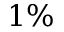Convert formula to latex. <formula><loc_0><loc_0><loc_500><loc_500>1 \%</formula> 